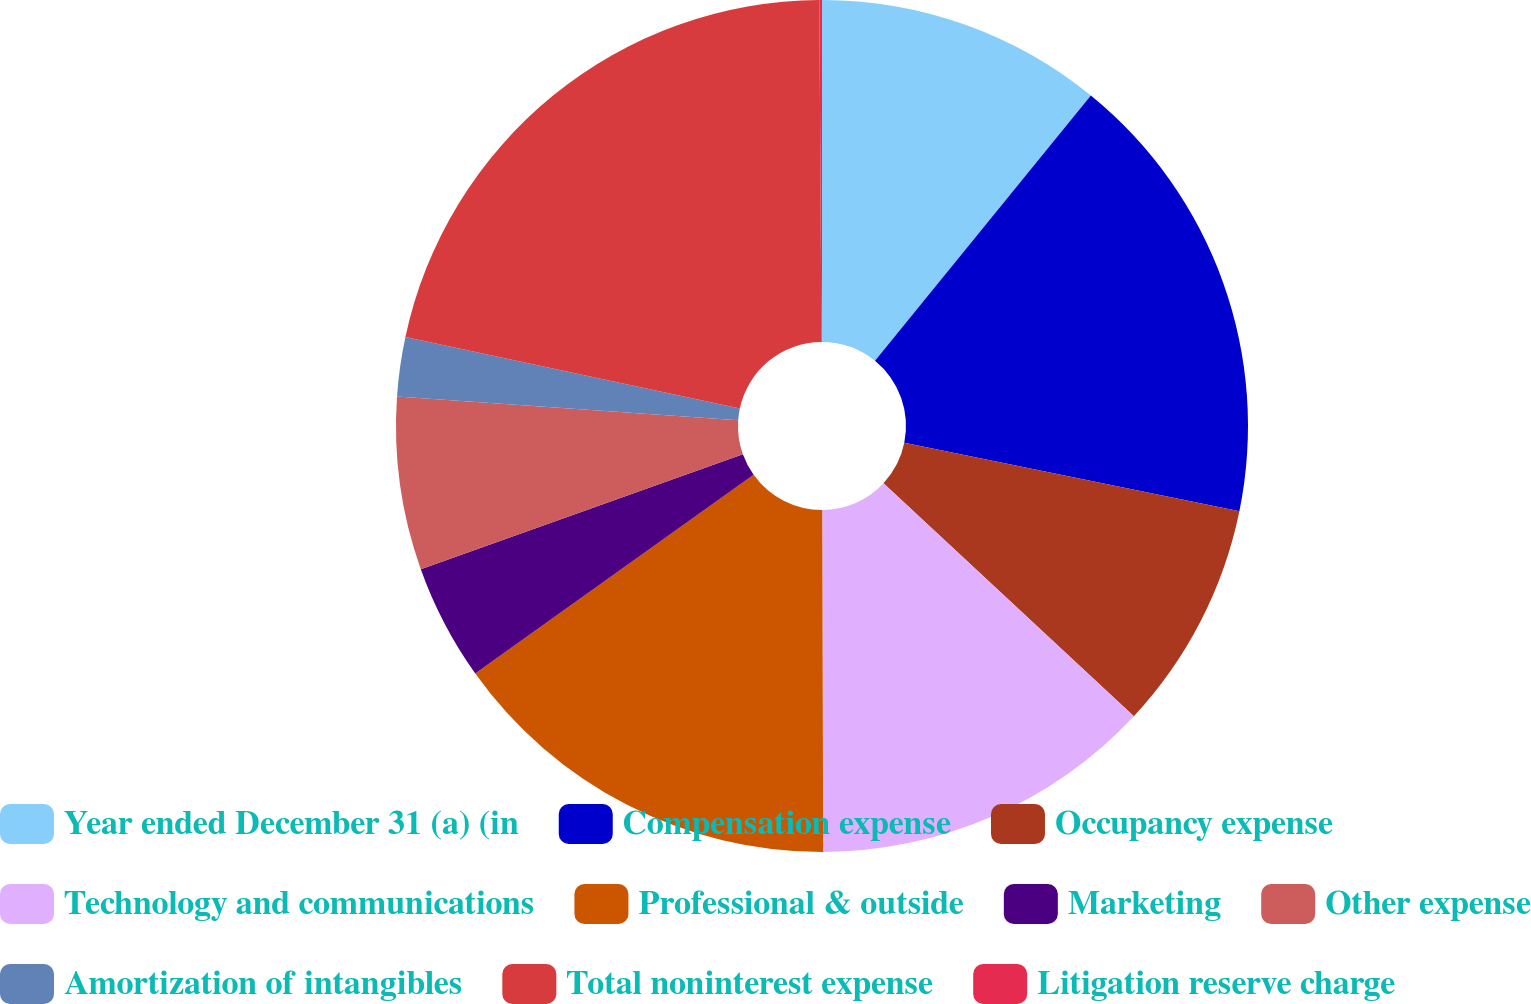<chart> <loc_0><loc_0><loc_500><loc_500><pie_chart><fcel>Year ended December 31 (a) (in<fcel>Compensation expense<fcel>Occupancy expense<fcel>Technology and communications<fcel>Professional & outside<fcel>Marketing<fcel>Other expense<fcel>Amortization of intangibles<fcel>Total noninterest expense<fcel>Litigation reserve charge<nl><fcel>10.87%<fcel>17.34%<fcel>8.72%<fcel>13.03%<fcel>15.18%<fcel>4.41%<fcel>6.56%<fcel>2.25%<fcel>21.55%<fcel>0.1%<nl></chart> 